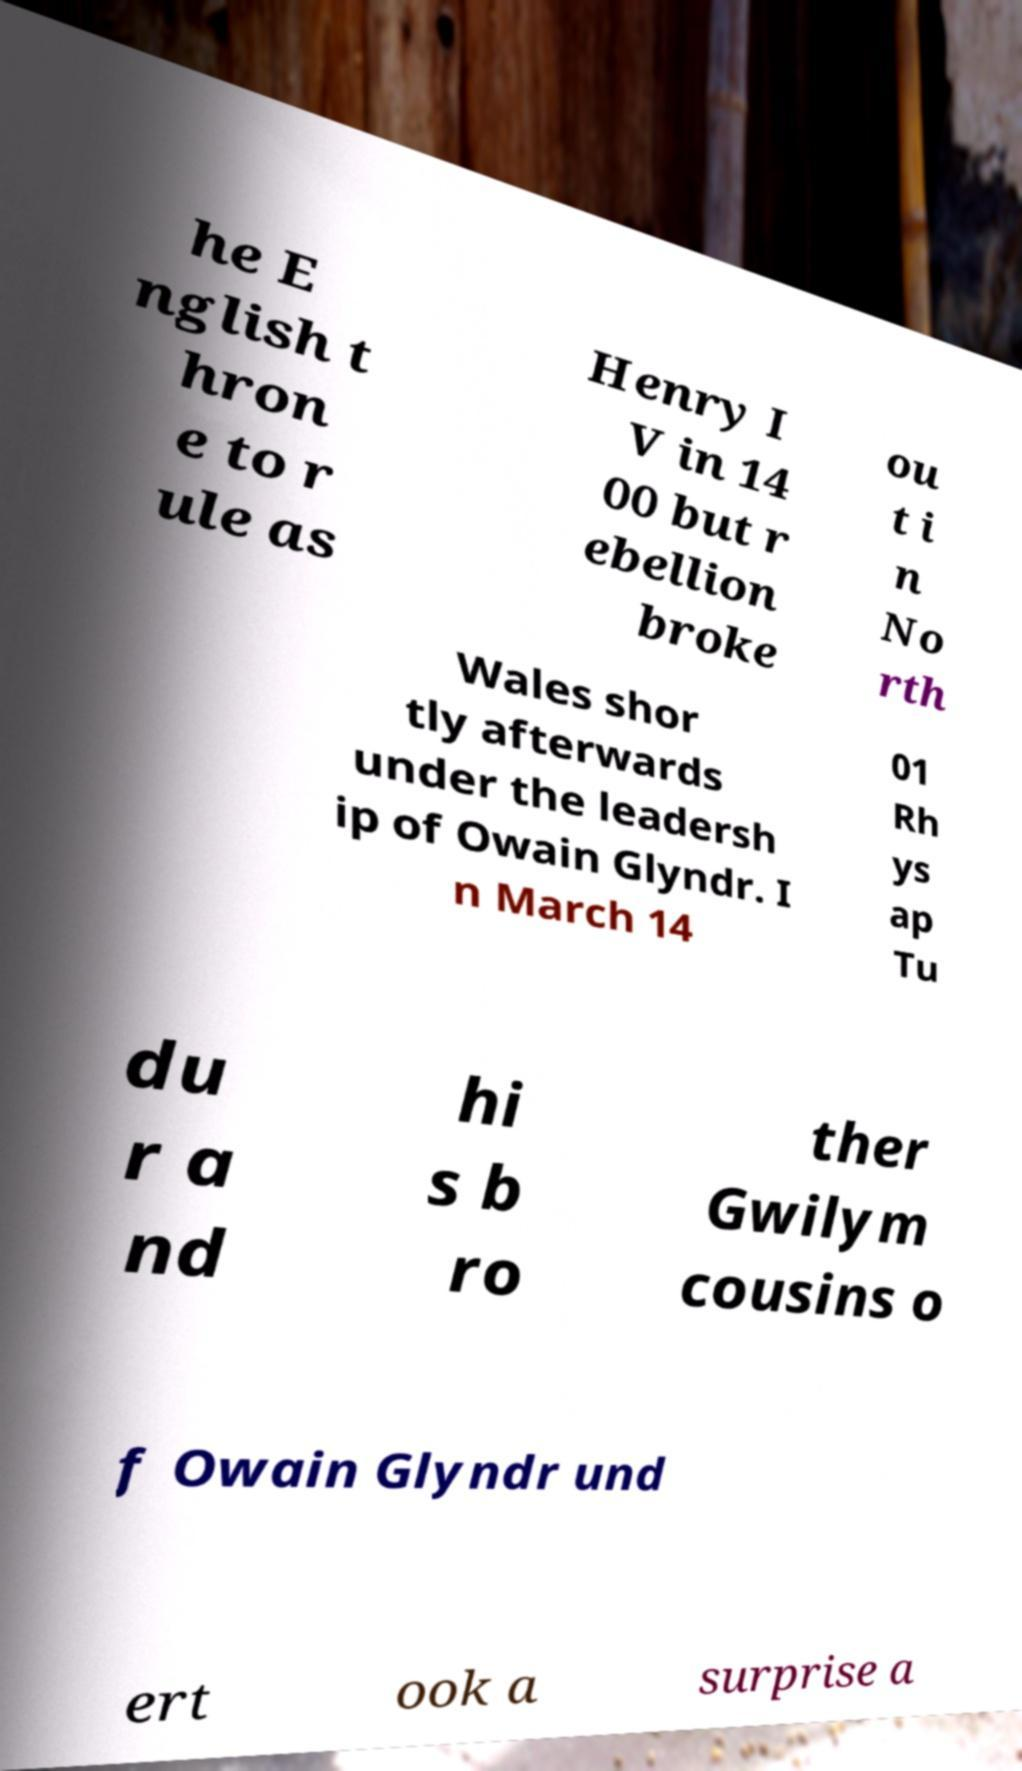Could you assist in decoding the text presented in this image and type it out clearly? he E nglish t hron e to r ule as Henry I V in 14 00 but r ebellion broke ou t i n No rth Wales shor tly afterwards under the leadersh ip of Owain Glyndr. I n March 14 01 Rh ys ap Tu du r a nd hi s b ro ther Gwilym cousins o f Owain Glyndr und ert ook a surprise a 